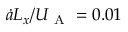<formula> <loc_0><loc_0><loc_500><loc_500>\dot { a } L _ { x } / U _ { A } = 0 . 0 1</formula> 